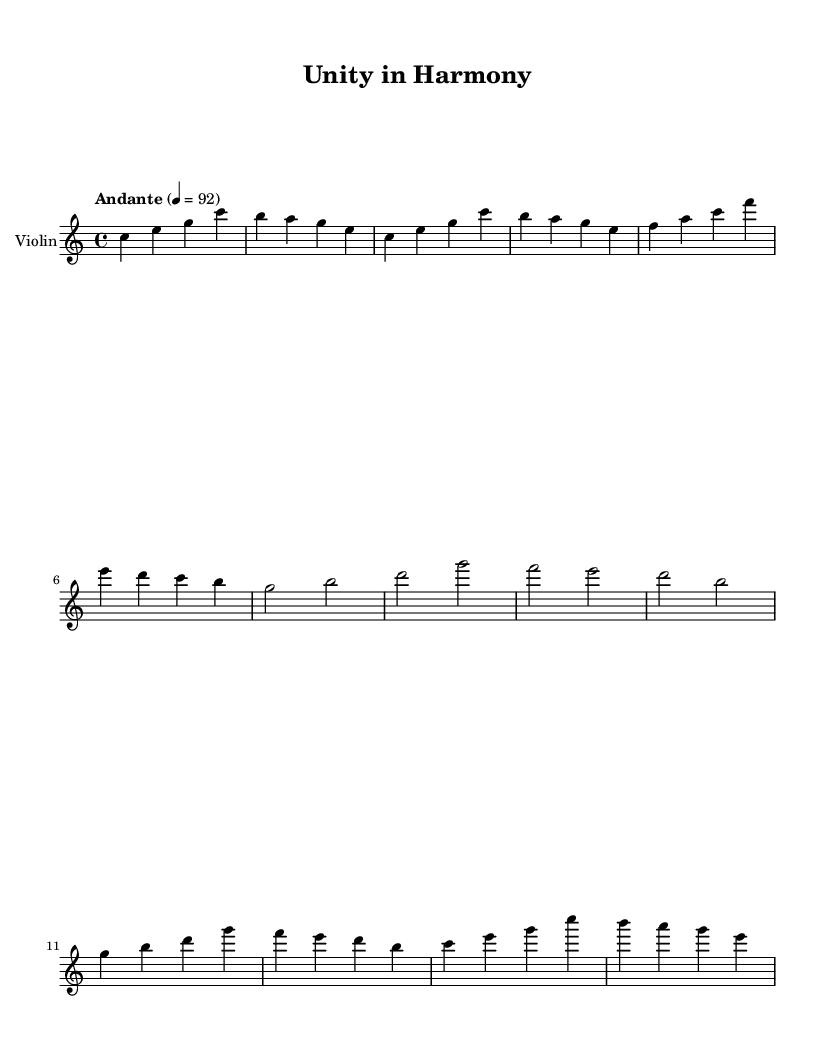What is the key signature of this music? The key signature is indicated at the beginning of the sheet music. It shows no sharps or flats, indicating a C major key.
Answer: C major What is the time signature of this score? The time signature is shown at the beginning of the piece. It is 4/4, indicating four beats per measure.
Answer: 4/4 What is the tempo marking given in the piece? The tempo marking is typically provided in the score. Here, it is indicated as "Andante" with a metronome mark of 92, suggesting a moderate pace.
Answer: Andante, 92 How many measures are there in the introduction section? By counting the measures in the introduction part of the score, we see it consists of 2 measures.
Answer: 2 Which instrument is indicated for this score? The instrument specified at the start of the score is clearly labeled. It indicates that the music is for the Violin.
Answer: Violin What is the name of the main theme in this piece? The themes are labeled in the score; the piece has a Main Theme A and Main Theme B. The first identifiable theme from the score is Main Theme A.
Answer: Main Theme A How does the bridge section differ in length from Main Theme A? To compare lengths, we count the measures: Main Theme A has 4 measures while the bridge section has 3 measures, indicating it is shorter by one measure.
Answer: Shorter by one measure 